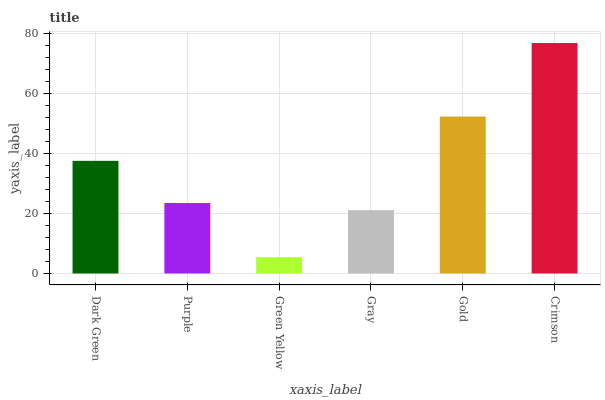Is Green Yellow the minimum?
Answer yes or no. Yes. Is Crimson the maximum?
Answer yes or no. Yes. Is Purple the minimum?
Answer yes or no. No. Is Purple the maximum?
Answer yes or no. No. Is Dark Green greater than Purple?
Answer yes or no. Yes. Is Purple less than Dark Green?
Answer yes or no. Yes. Is Purple greater than Dark Green?
Answer yes or no. No. Is Dark Green less than Purple?
Answer yes or no. No. Is Dark Green the high median?
Answer yes or no. Yes. Is Purple the low median?
Answer yes or no. Yes. Is Green Yellow the high median?
Answer yes or no. No. Is Gray the low median?
Answer yes or no. No. 